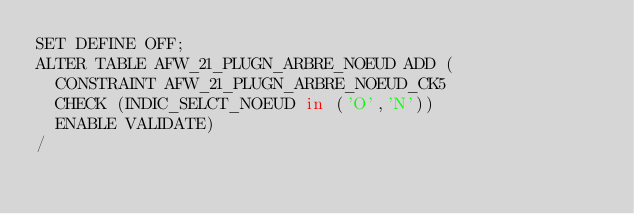Convert code to text. <code><loc_0><loc_0><loc_500><loc_500><_SQL_>SET DEFINE OFF;
ALTER TABLE AFW_21_PLUGN_ARBRE_NOEUD ADD (
  CONSTRAINT AFW_21_PLUGN_ARBRE_NOEUD_CK5
  CHECK (INDIC_SELCT_NOEUD in ('O','N'))
  ENABLE VALIDATE)
/
</code> 